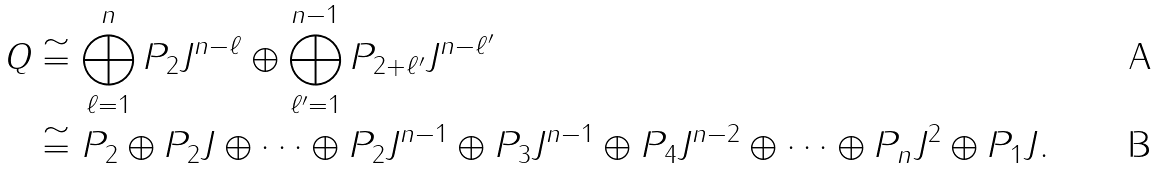Convert formula to latex. <formula><loc_0><loc_0><loc_500><loc_500>Q & \cong \bigoplus _ { \ell = 1 } ^ { n } P _ { 2 } J ^ { n - \ell } \oplus \bigoplus _ { \ell ^ { \prime } = 1 } ^ { n - 1 } P _ { 2 + \ell ^ { \prime } } J ^ { n - \ell ^ { \prime } } \\ & \cong P _ { 2 } \oplus P _ { 2 } J \oplus \cdots \oplus P _ { 2 } J ^ { n - 1 } \oplus P _ { 3 } J ^ { n - 1 } \oplus P _ { 4 } J ^ { n - 2 } \oplus \cdots \oplus P _ { n } J ^ { 2 } \oplus P _ { 1 } J .</formula> 